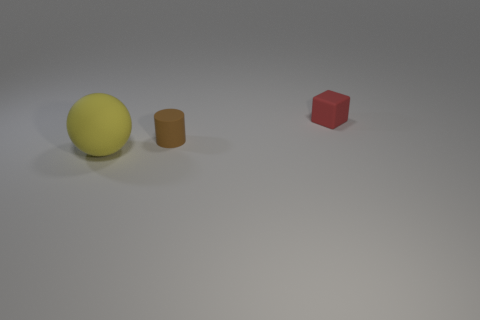How many things are either objects in front of the brown rubber cylinder or big yellow matte spheres? The image contains one large yellow matte sphere and one brown cylinder. There are no objects in front of the cylinder, making the total count one big yellow matte sphere. 